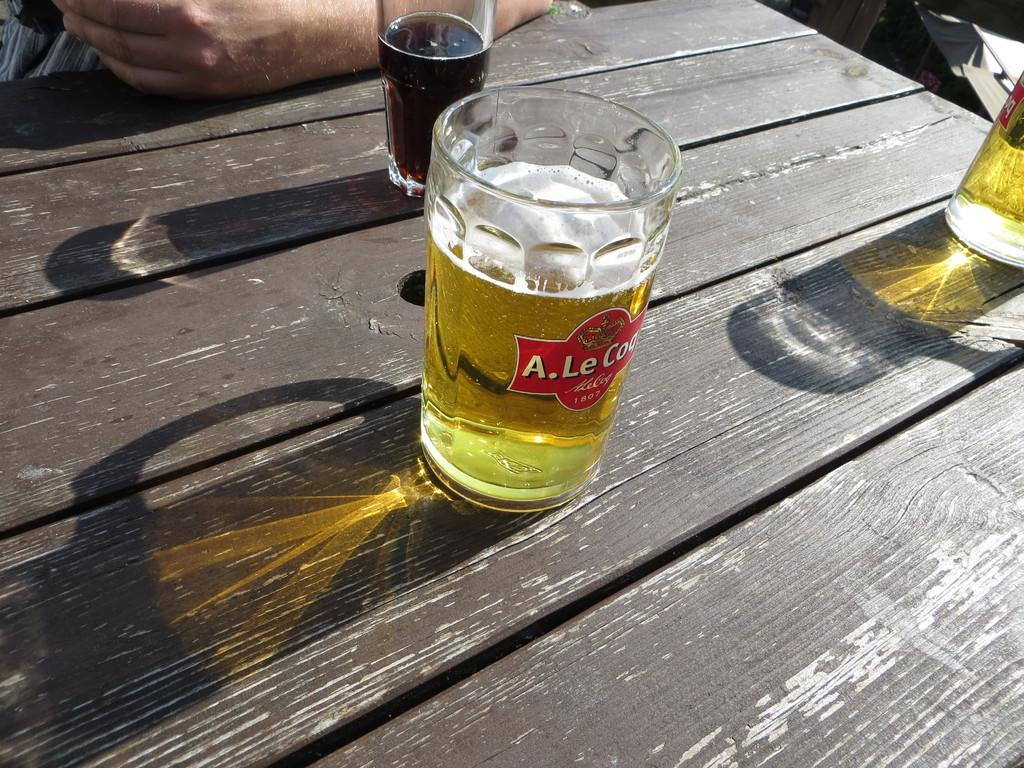What is the main object in the center of the image? There is a table in the center of the image. What is placed on the table? Glasses containing a drink are placed on the table. Can you describe any other visible elements in the image? A person's hand is visible at the top of the image. How many cars are parked on the table in the image? There are no cars present on the table in the image. What type of whip is being used by the person in the image? There is no whip visible in the image; only a person's hand is present. 